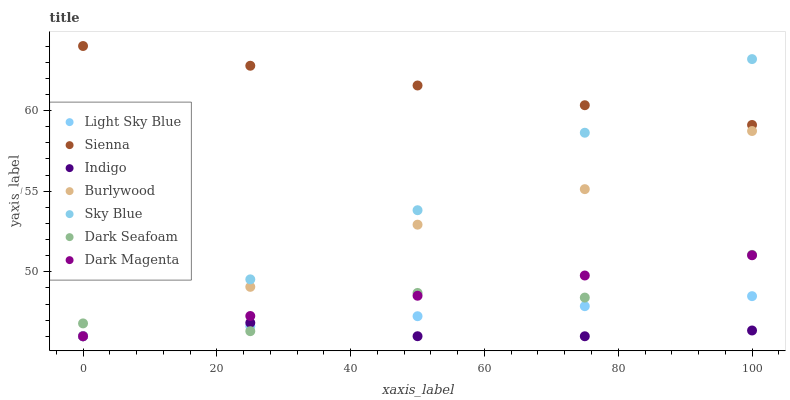Does Indigo have the minimum area under the curve?
Answer yes or no. Yes. Does Sienna have the maximum area under the curve?
Answer yes or no. Yes. Does Dark Magenta have the minimum area under the curve?
Answer yes or no. No. Does Dark Magenta have the maximum area under the curve?
Answer yes or no. No. Is Light Sky Blue the smoothest?
Answer yes or no. Yes. Is Dark Seafoam the roughest?
Answer yes or no. Yes. Is Dark Magenta the smoothest?
Answer yes or no. No. Is Dark Magenta the roughest?
Answer yes or no. No. Does Indigo have the lowest value?
Answer yes or no. Yes. Does Sienna have the lowest value?
Answer yes or no. No. Does Sienna have the highest value?
Answer yes or no. Yes. Does Dark Magenta have the highest value?
Answer yes or no. No. Is Dark Seafoam less than Sienna?
Answer yes or no. Yes. Is Sienna greater than Light Sky Blue?
Answer yes or no. Yes. Does Light Sky Blue intersect Dark Magenta?
Answer yes or no. Yes. Is Light Sky Blue less than Dark Magenta?
Answer yes or no. No. Is Light Sky Blue greater than Dark Magenta?
Answer yes or no. No. Does Dark Seafoam intersect Sienna?
Answer yes or no. No. 